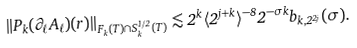Convert formula to latex. <formula><loc_0><loc_0><loc_500><loc_500>\| P _ { k } ( \partial _ { \ell } A _ { \ell } ) ( r ) \| _ { F _ { k } ( T ) \cap S _ { k } ^ { 1 / 2 } ( T ) } \lesssim 2 ^ { k } \langle 2 ^ { j + k } \rangle ^ { - 8 } 2 ^ { - \sigma k } b _ { k , 2 ^ { 2 j } } ( \sigma ) .</formula> 